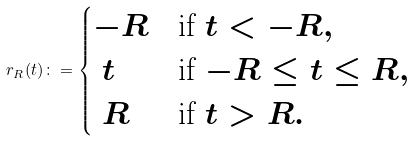Convert formula to latex. <formula><loc_0><loc_0><loc_500><loc_500>r _ { R } ( t ) \colon = \begin{cases} - R & \text {if $t < -R$} , \\ \ t & \text {if $-R \leq t \leq R$} , \\ \ R & \text {if $t > R$} . \end{cases}</formula> 